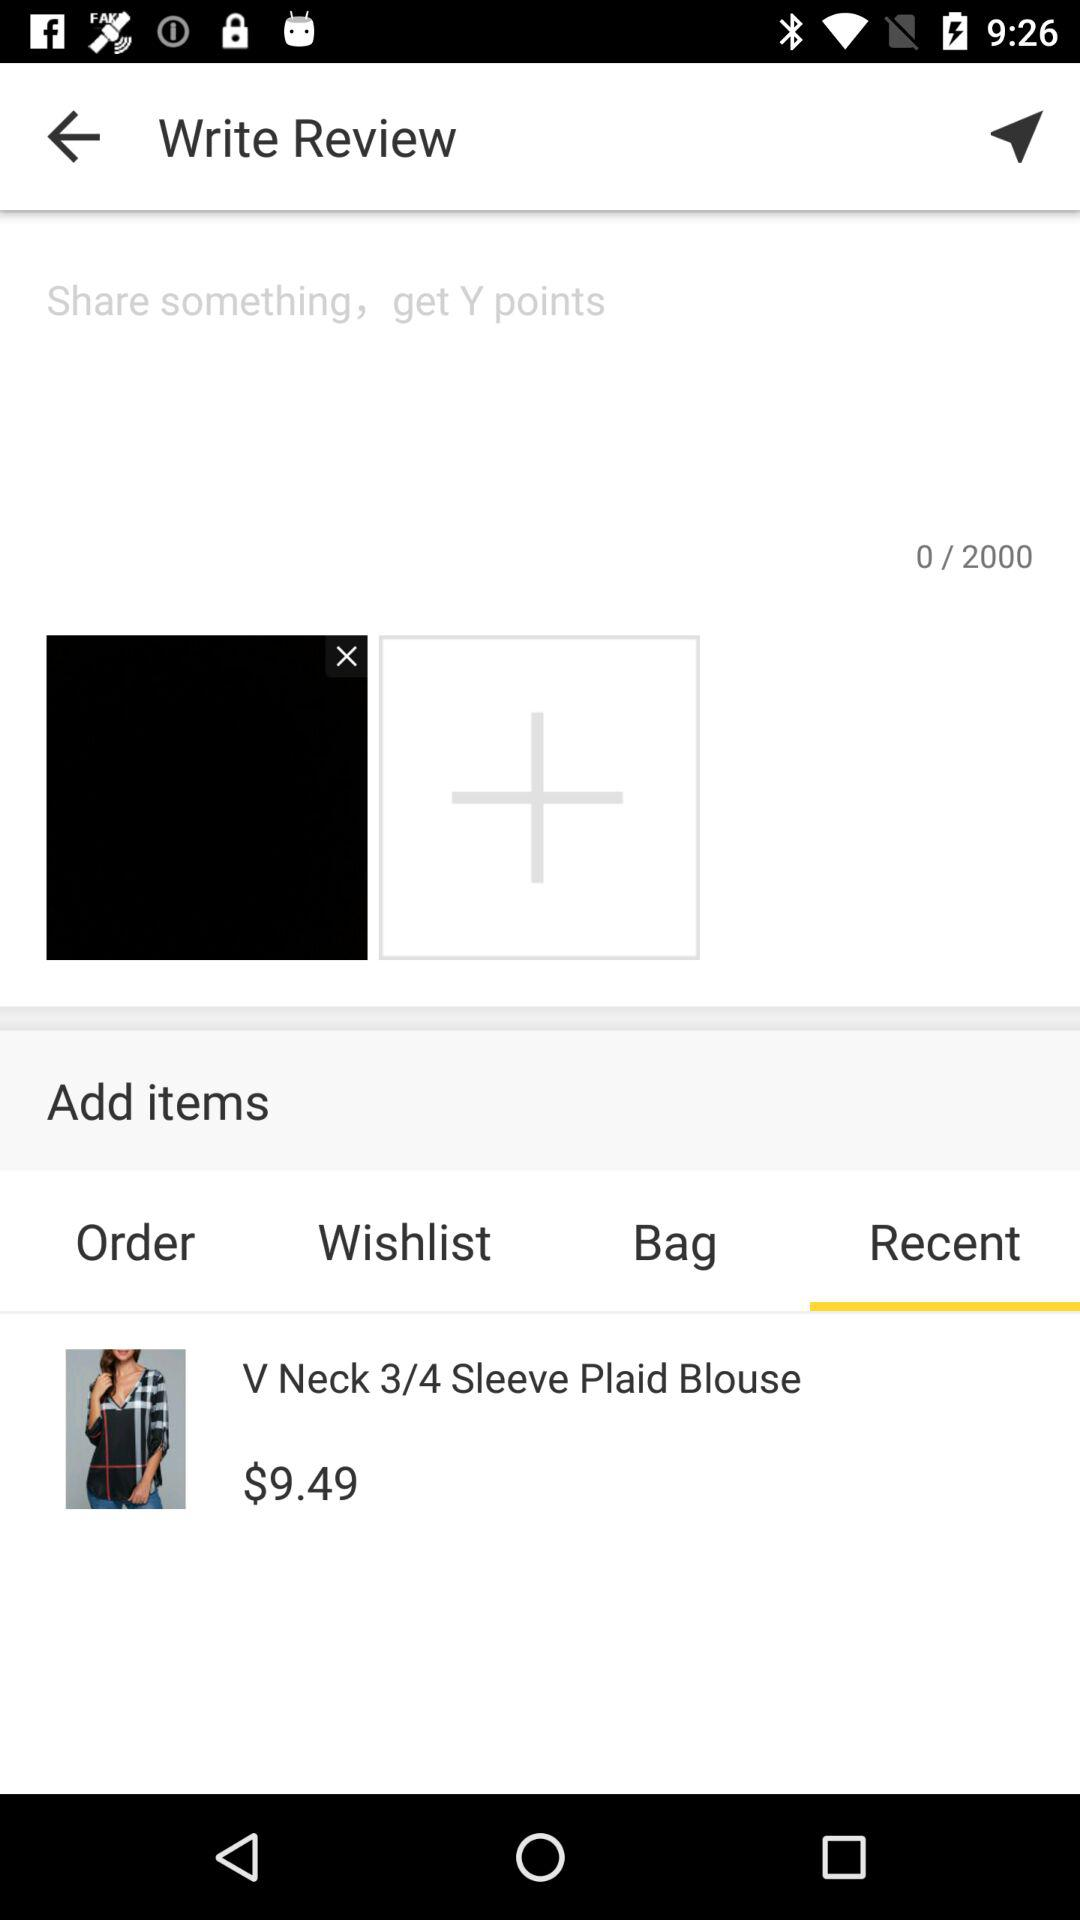What tab is selected? The selected tab is "Recent". 